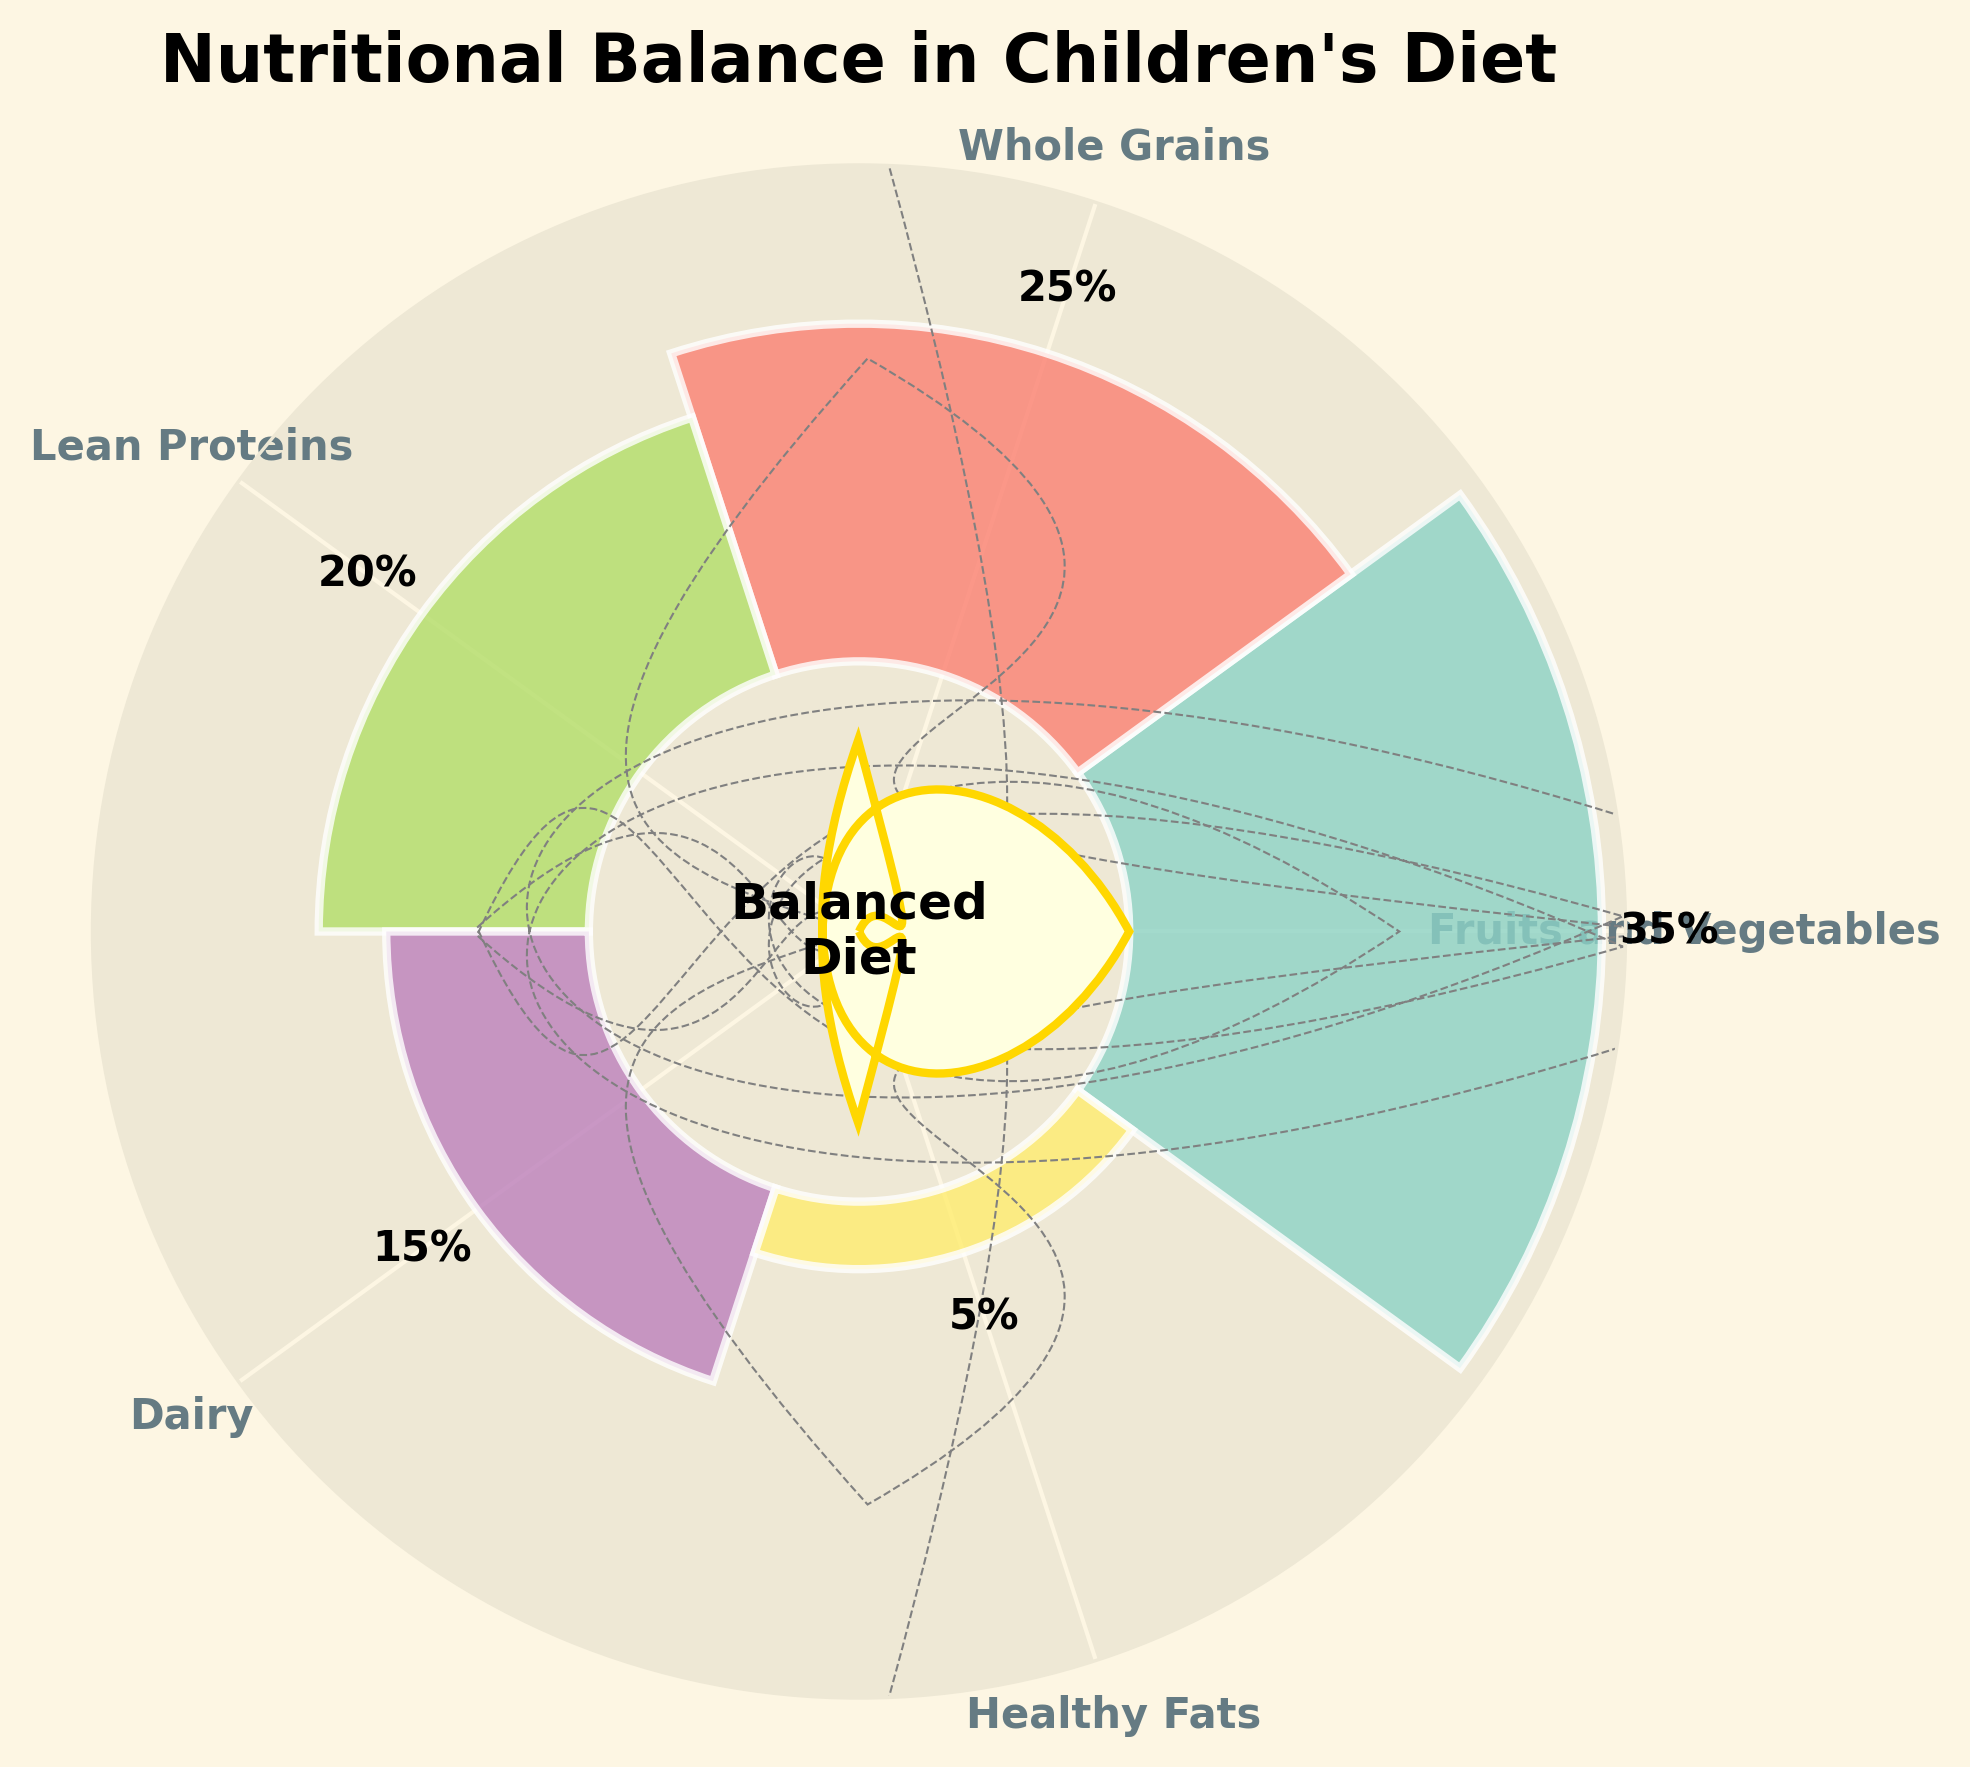What is the title of the figure? The title is usually located at the top of the figure. In this case, it reads "Nutritional Balance in Children's Diet".
Answer: Nutritional Balance in Children's Diet How much percentage do Fruits and Vegetables account for? Look at the segment labeled "Fruits and Vegetables" and find the percentage value associated with it.
Answer: 35% Which food group has the smallest percentage? Identify the smallest bar in the chart and check the corresponding label to find the name of the food group.
Answer: Healthy Fats What is the combined percentage of Whole Grains and Lean Proteins? Find the percentage of Whole Grains and Lean Proteins, then add these values together: 25% + 20% = 45%.
Answer: 45% Among the major food groups, which ones have a percentage greater than 20%? Identify the bars that extend beyond the 20% mark and check their corresponding labels. In this case, Fruits and Vegetables (35%) and Whole Grains (25%).
Answer: Fruits and Vegetables, Whole Grains How do Dairy compare to Lean Proteins in terms of percentage? Compare the heights of the Dairy bar (15%) and the Lean Proteins bar (20%). Since 15% is less than 20%, Dairy is consumed in a smaller proportion compared to Lean Proteins.
Answer: Less What direction does the sector for Healthy Fats point to in polar coordinates (in radians)? Locate the sector for Healthy Fats and check its position. It should roughly point between the angles corresponding to its segment.
Answer: Between 1.2566 to 1.884 radians What is the average percentage of Fruits and Vegetables, Whole Grains, and Lean Proteins? Add the percentages of these groups and divide by the number of groups: (35 + 25 + 20) / 3 = 80 / 3 = 26.67%.
Answer: 26.67% Which two food groups together make up 50% of the diet? Identify pairs of food groups whose percentages add up to 50%. The pair Whole Grains (25%) and Lean Proteins (20%) together make 45%, but Fruits and Vegetables (35%) and Dairy (15%) add up to 50%.
Answer: Fruits and Vegetables, Dairy 